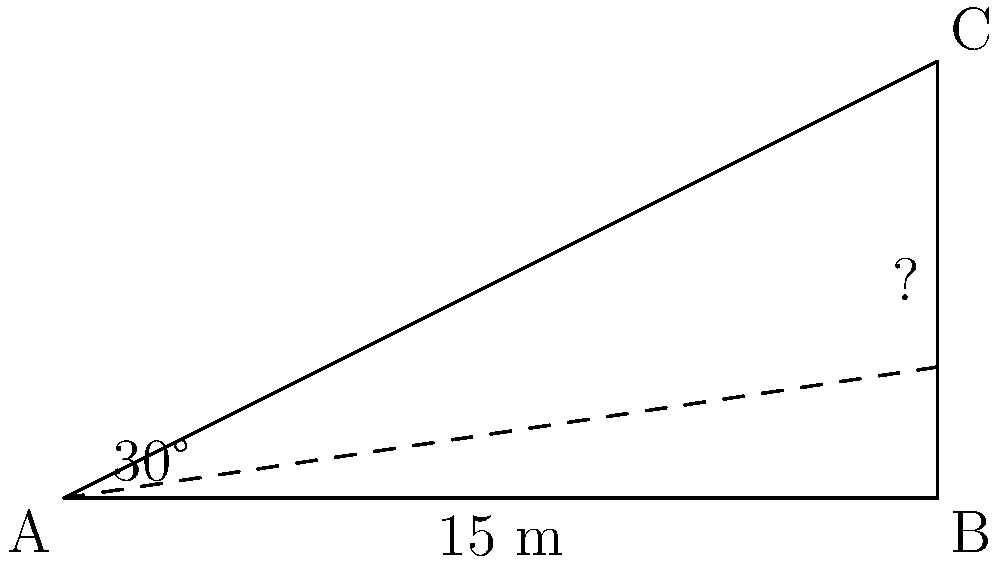A protective barrier is being constructed in a conflict zone. From a vantage point A, you can see the top of the barrier at point C. The distance from point A to the base of the barrier (point B) is 15 meters. The angle of elevation from point A to the top of the barrier (point C) is 30°. Using the tangent function, calculate the height of the protective barrier to the nearest tenth of a meter. To solve this problem, we'll use the tangent function, which relates the opposite side to the adjacent side in a right triangle. Here's the step-by-step solution:

1) In this right triangle, we know:
   - The adjacent side (distance AB) = 15 meters
   - The angle of elevation = 30°
   - We need to find the opposite side (height BC)

2) The tangent function is defined as:
   $\tan \theta = \frac{\text{opposite}}{\text{adjacent}}$

3) We can rearrange this to solve for the opposite side:
   $\text{opposite} = \text{adjacent} \times \tan \theta$

4) Plugging in our known values:
   $\text{height} = 15 \times \tan 30°$

5) $\tan 30°$ is a standard angle, which equals $\frac{1}{\sqrt{3}}$ or approximately 0.5774

6) Calculate:
   $\text{height} = 15 \times 0.5774 = 8.661$ meters

7) Rounding to the nearest tenth:
   $\text{height} \approx 8.7$ meters

Therefore, the height of the protective barrier is approximately 8.7 meters.
Answer: 8.7 meters 